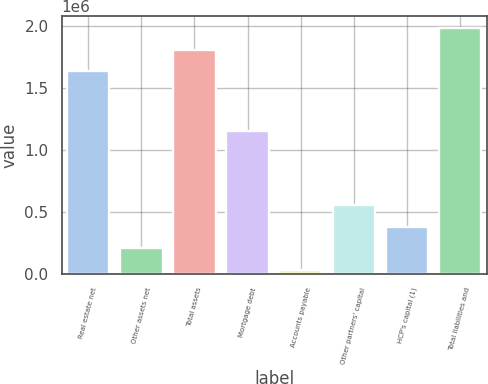<chart> <loc_0><loc_0><loc_500><loc_500><bar_chart><fcel>Real estate net<fcel>Other assets net<fcel>Total assets<fcel>Mortgage debt<fcel>Accounts payable<fcel>Other partners' capital<fcel>HCP's capital (1)<fcel>Total liabilities and<nl><fcel>1.63321e+06<fcel>205400<fcel>1.80649e+06<fcel>1.14884e+06<fcel>32120<fcel>551961<fcel>378681<fcel>1.97977e+06<nl></chart> 